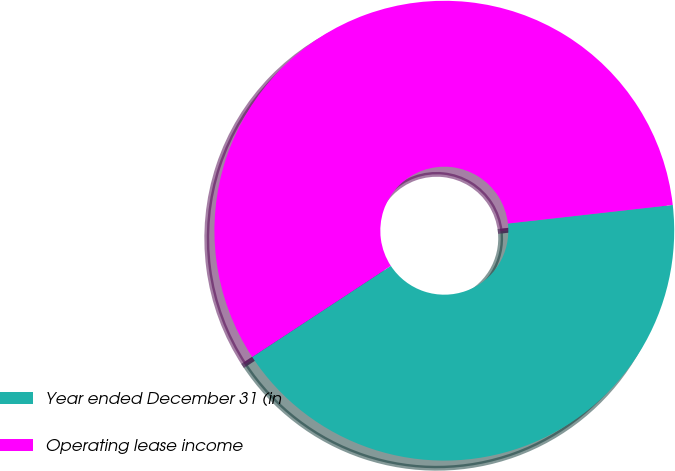<chart> <loc_0><loc_0><loc_500><loc_500><pie_chart><fcel>Year ended December 31 (in<fcel>Operating lease income<nl><fcel>42.53%<fcel>57.47%<nl></chart> 